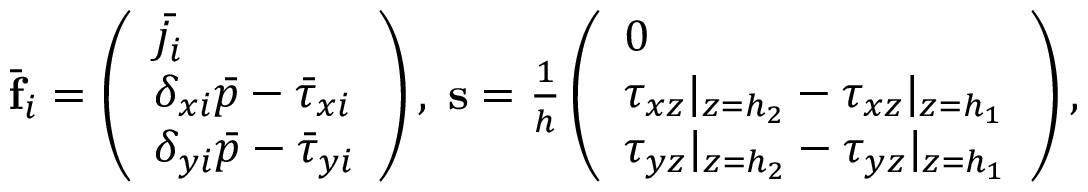Convert formula to latex. <formula><loc_0><loc_0><loc_500><loc_500>\begin{array} { r } { \bar { f } _ { i } = \left ( \begin{array} { l } { \bar { j _ { i } } } \\ { \delta _ { x i } \bar { p } - \bar { \tau } _ { x i } } \\ { \delta _ { y i } \bar { p } - \bar { \tau } _ { y i } } \end{array} \right ) , \, s = \frac { 1 } { h } \left ( \begin{array} { l } { 0 } \\ { \tau _ { x z } | _ { z = h _ { 2 } } - \tau _ { x z } | _ { z = h _ { 1 } } } \\ { \tau _ { y z } | _ { z = h _ { 2 } } - \tau _ { y z } | _ { z = h _ { 1 } } } \end{array} \right ) , } \end{array}</formula> 